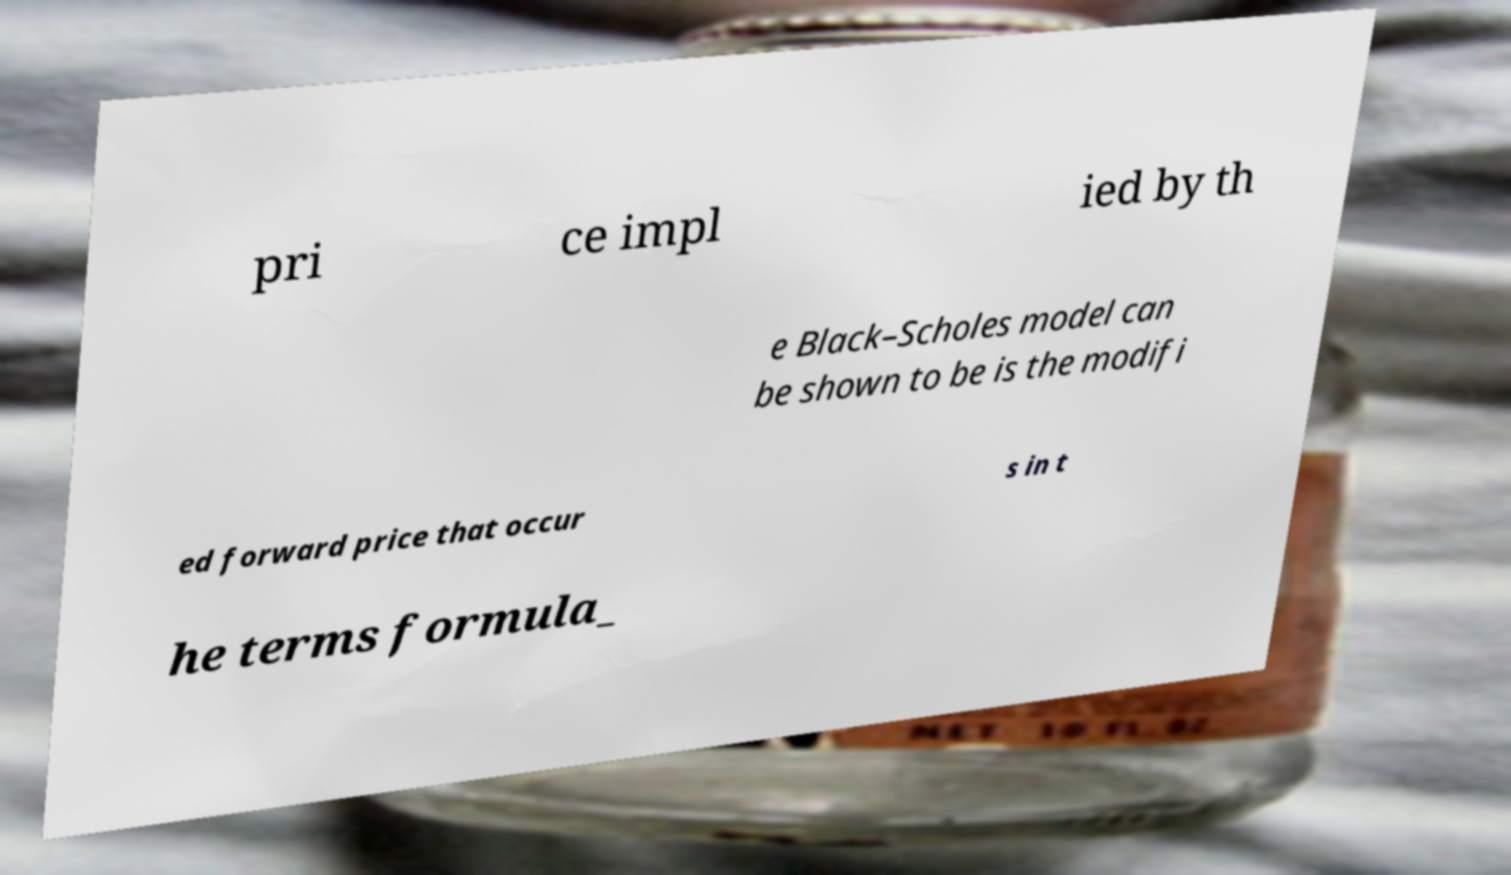I need the written content from this picture converted into text. Can you do that? pri ce impl ied by th e Black–Scholes model can be shown to be is the modifi ed forward price that occur s in t he terms formula_ 